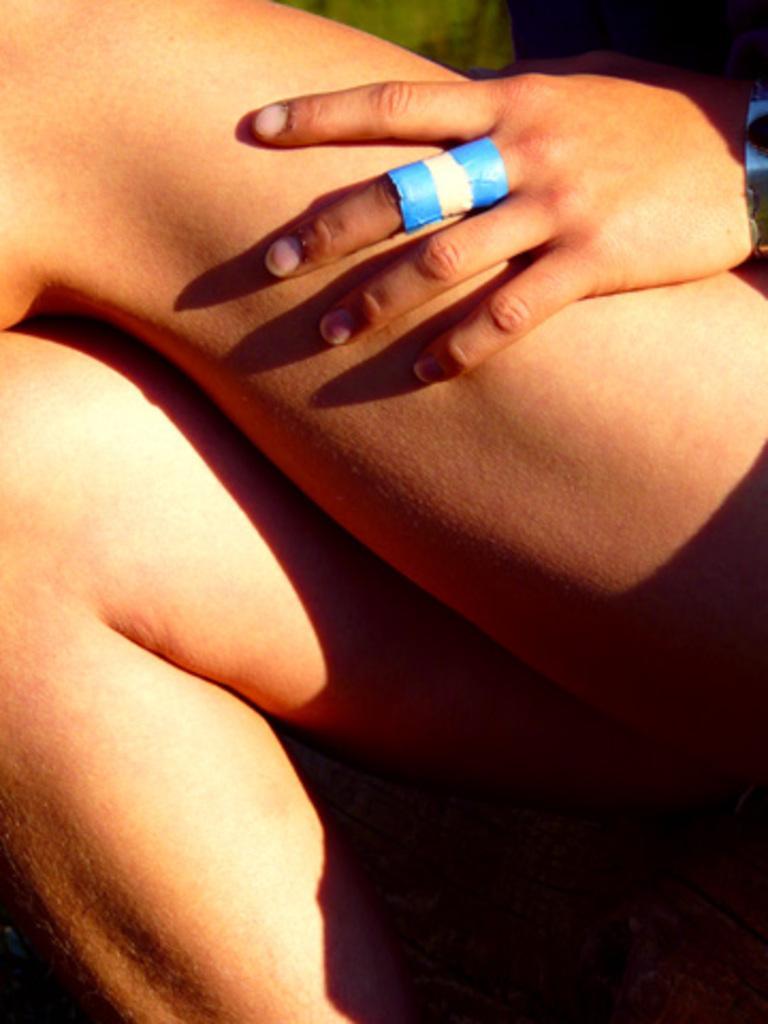Please provide a concise description of this image. In this image I can see a person's legs and hand. To the hand I can see a blue color paper. 